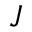<formula> <loc_0><loc_0><loc_500><loc_500>J</formula> 